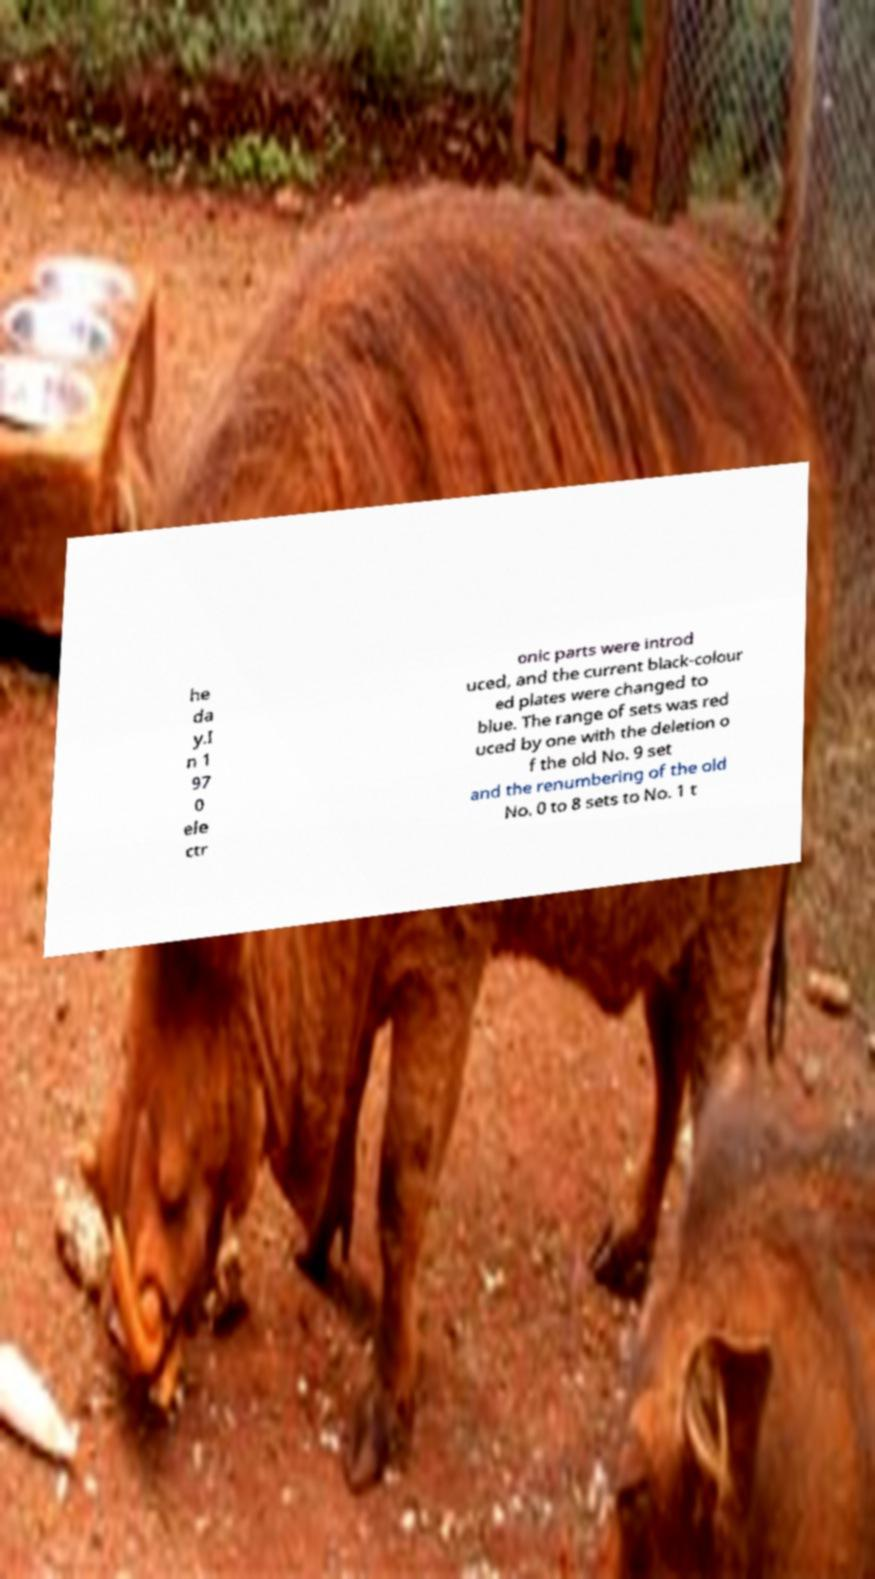I need the written content from this picture converted into text. Can you do that? he da y.I n 1 97 0 ele ctr onic parts were introd uced, and the current black-colour ed plates were changed to blue. The range of sets was red uced by one with the deletion o f the old No. 9 set and the renumbering of the old No. 0 to 8 sets to No. 1 t 